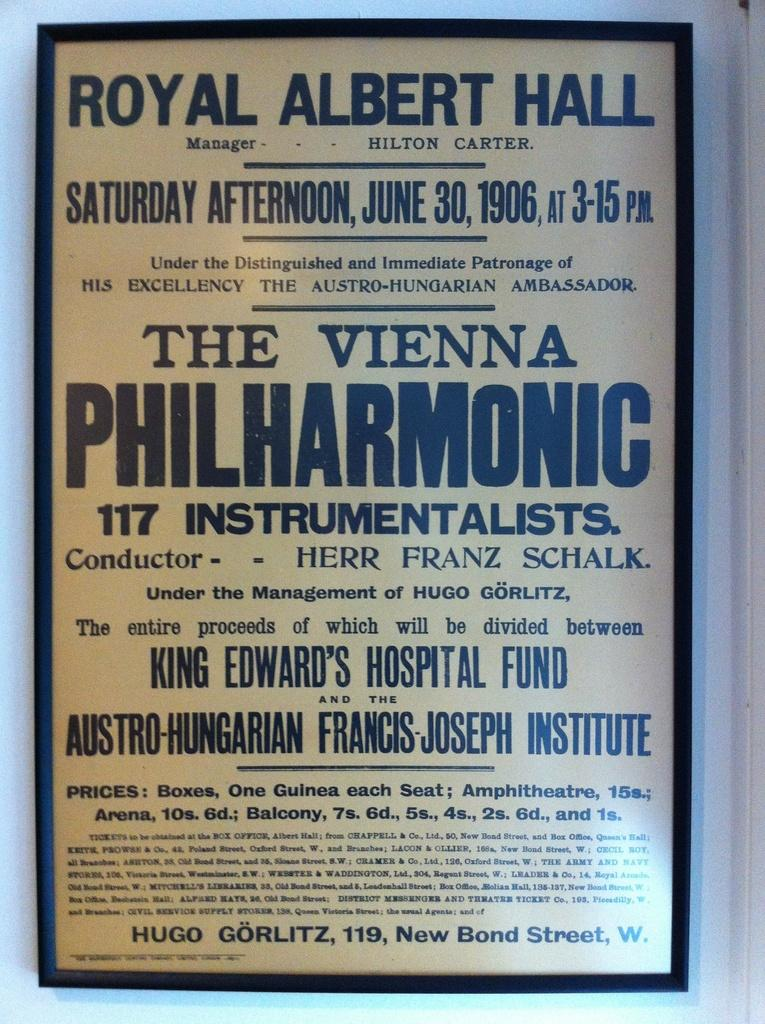<image>
Relay a brief, clear account of the picture shown. the vienna is written on a piece of paper 